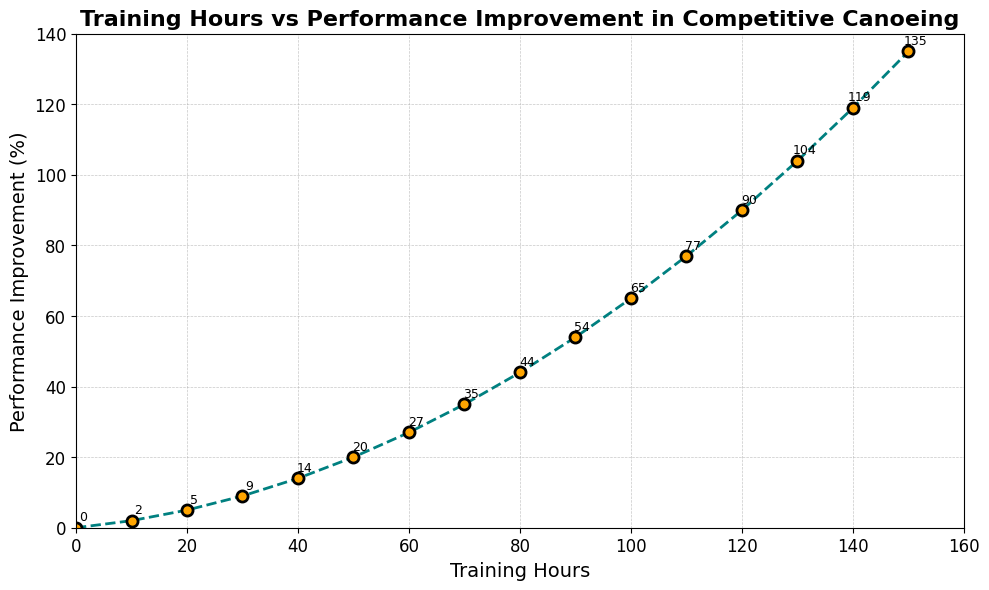What's the performance improvement percentage after 70 training hours? The line chart shows that at 70 training hours, the performance improvement is annotated at the corresponding point on the graph.
Answer: 35% What is the difference in performance improvement percentage between 60 and 110 training hours? The performance improvement at 60 training hours is 27%, and at 110 training hours it is 77%. The difference is calculated by subtracting 27% from 77%.
Answer: 50% How much more improvement does 150 training hours give compared to 30 training hours? The improvement at 150 training hours is 135%, and at 30 training hours it is 9%. By subtracting 9% from 135%, we can determine the additional improvement.
Answer: 126% Which training hour mark shows the greatest performance improvement percentage and what is it? Reviewing the annotations on the line chart, the highest value is at 150 training hours, with a performance improvement of 135%.
Answer: 150 hours, 135% Is the performance improvement rate accelerating, decelerating, or linear as training hours increase? The line chart exhibits a non-linear increase; the improvement slope becomes steeper as training hours increase, indicating an accelerating rate.
Answer: Accelerating What’s the average performance improvement percentage over the first 100 training hours? Summing the percentages from 0 to 100 training hours (0 + 2 + 5 + 9 + 14 + 20 + 27 + 35 + 44 + 54 + 65 = 275) and dividing by the number of points (11) gives us the average.
Answer: 25% After how many training hours does the performance improvement percentage exceed 50% for the first time? Looking at the chart, the performance improvement exceeds 50% between 80 and 90 training hours, reaching 54% at 90 training hours.
Answer: 90 hours Between which two consecutive training hour marks is the largest increase in performance improvement percentage observed? Observing the increments, the largest increase appears between 120 and 130 training hours, where the improvement percentage jumps from 90% to 104%.
Answer: Between 120 and 130 hours What is the approximate performance improvement percentage at the midpoint (75 hours) between 50 and 100 training hours? The score may be approximated by averaging the improvements at 70 and 80 hours: (35% + 44%) / 2 = 39.5%.
Answer: 39.5% What trend can be observed regarding performance improvement as training hours increase? The line chart illustrates an upward trajectory, with performance improvement increasing at an accelerating rate as training hours increase.
Answer: Increasing at an accelerating rate 